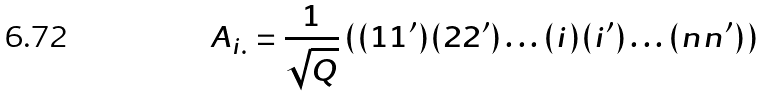Convert formula to latex. <formula><loc_0><loc_0><loc_500><loc_500>A _ { i . } = \frac { 1 } { \sqrt { Q } } \, ( ( 1 1 ^ { \prime } ) ( 2 2 ^ { \prime } ) \dots ( i ) ( i ^ { \prime } ) \dots ( n n ^ { \prime } ) )</formula> 